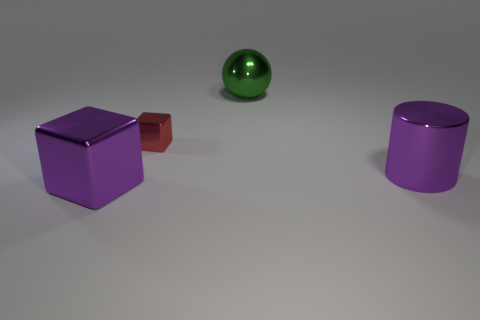What can you infer about the setting of these objects based on the image? The objects are placed within a neutral environment with a plain background and a soft shadow cast beneath each item, suggesting a source of light somewhere outside the frame. The uniformity of the lighting and the simplicity of the scene hint at a controlled setting, possibly a studio or an indoor space designed for photographing objects without any distractions. The lack of any defining features beyond the objects suggests that the focus is meant to be solely on the items themselves, emphasizing their shapes, colors, and materials. 